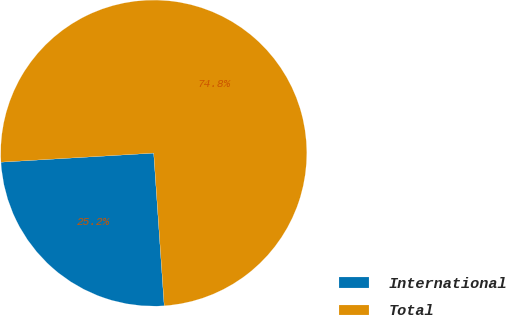Convert chart. <chart><loc_0><loc_0><loc_500><loc_500><pie_chart><fcel>International<fcel>Total<nl><fcel>25.15%<fcel>74.85%<nl></chart> 